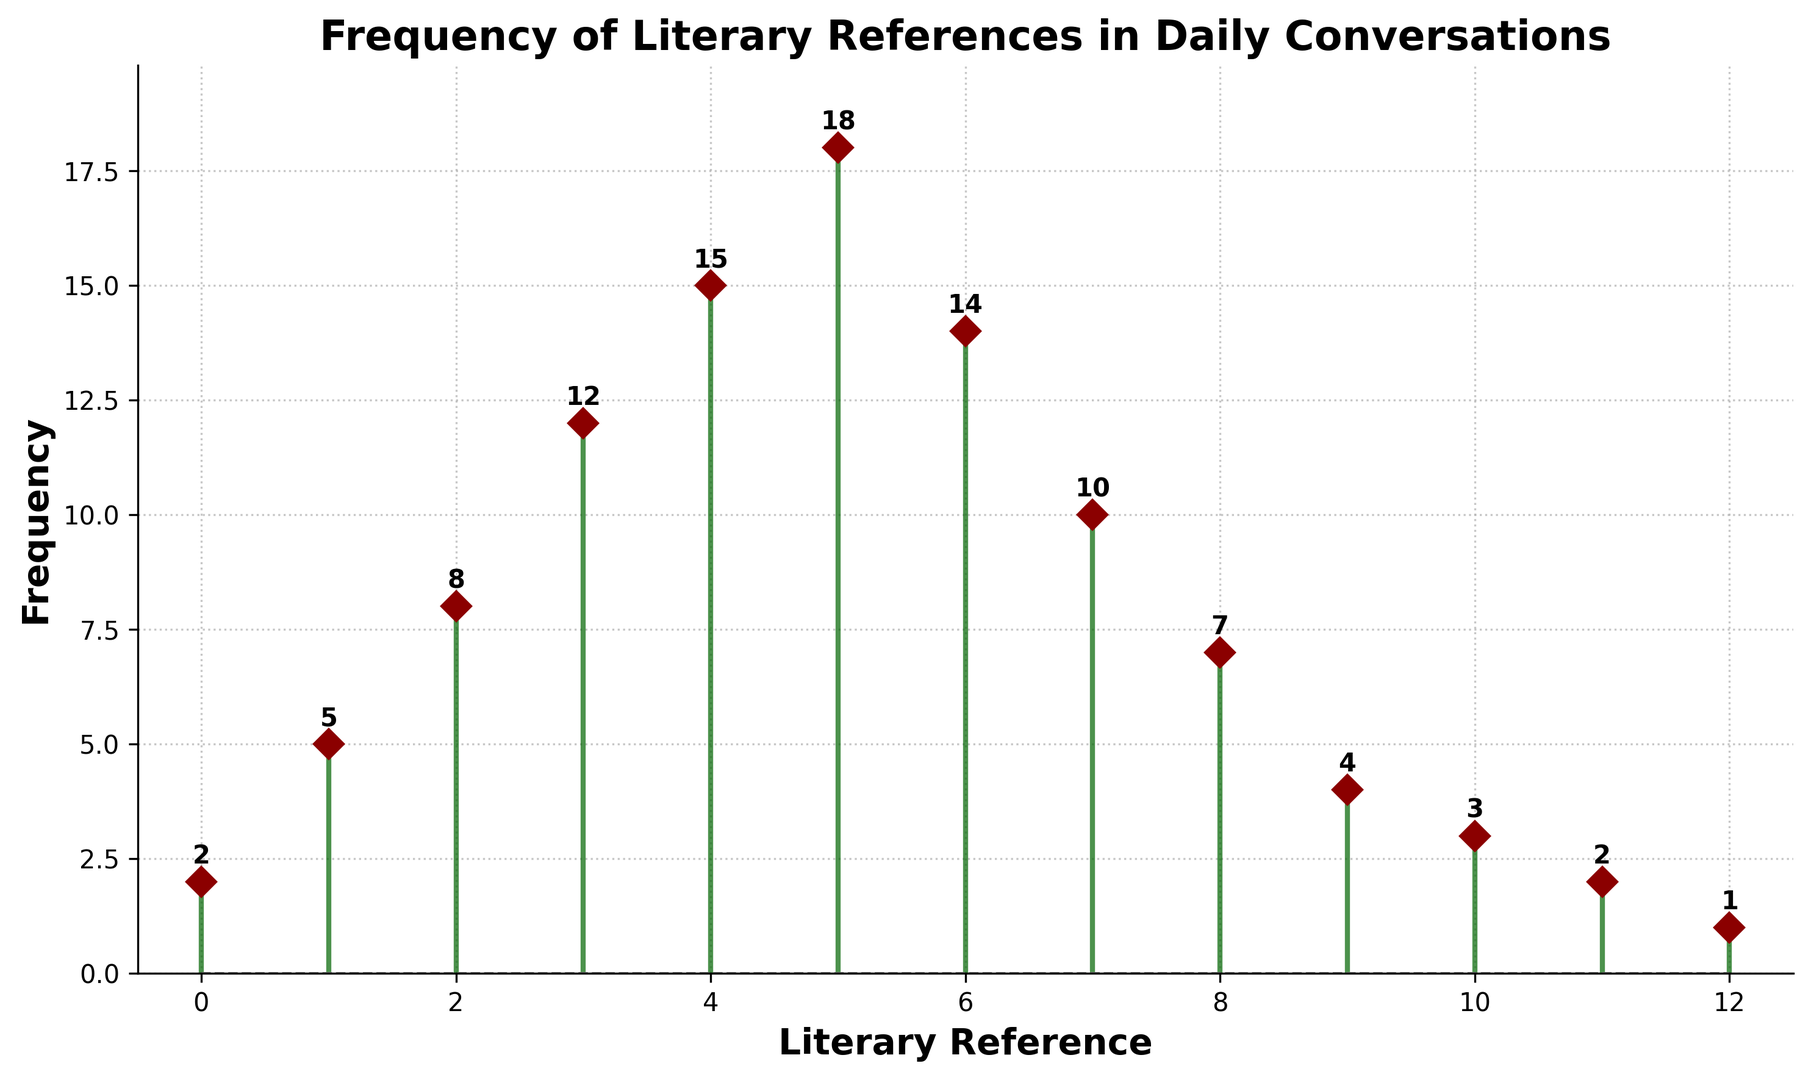What's the highest frequency of literary references? We need to find the peak value on the y-axis. Observing the figure, the highest point for the frequency is 18.
Answer: 18 Which literary reference frequency is used by 14 people? Look for the y-value of 14 and find the corresponding x-value. The x-value for which the y-value is 14 is 6.
Answer: 6 How many people use four literary references in their daily conversations? Find the x-value equal to 4, then look at its corresponding y-value, which illustrates the frequency. The y-value for x = 4 is 15.
Answer: 15 Identify the number of literary references most frequently mentioned in daily conversations. Observe the x-value corresponding to the highest y-value (peak). The highest frequency, which is 18, corresponds to the x-value 5.
Answer: 5 What's the difference between the highest and the lowest frequency of literary references? The highest frequency is 18, and the lowest frequency is 1. Calculating the difference: 18 - 1 = 17.
Answer: 17 Which literary references have a frequency less than 5? We need to check all the x-values where the y-values are less than 5. These x-values are 0, 9, 10, 11, and 12.
Answer: 0, 9, 10, 11, 12 What is the frequency when the number of literary references is doubled from 3 to 6? Find the frequencies for x=3 and x=6. The values are 12 and 14 respectively.
Answer: 12 and 14 Sum the frequencies of literary references from 2 to 4. Calculate the sum of y-values for x=2, x=3, and x=4. The frequencies are 8, 12, and 15 respectively. Adding them: 8 + 12 + 15 = 35.
Answer: 35 What is the visual indicator for the frequency data points? Identify the marker and color used in the figure. The markers are diamond-shaped and colored dark red, connected by dark green stemlines.
Answer: Dark red diamonds with dark green lines Compare the frequency of using 7 literary references to the frequency of using 8 literary references. Find the y-values for x = 7 and x = 8 from the plot. The values are 10 and 7 respectively. Compare them: 10 > 7.
Answer: 10 is greater than 7 